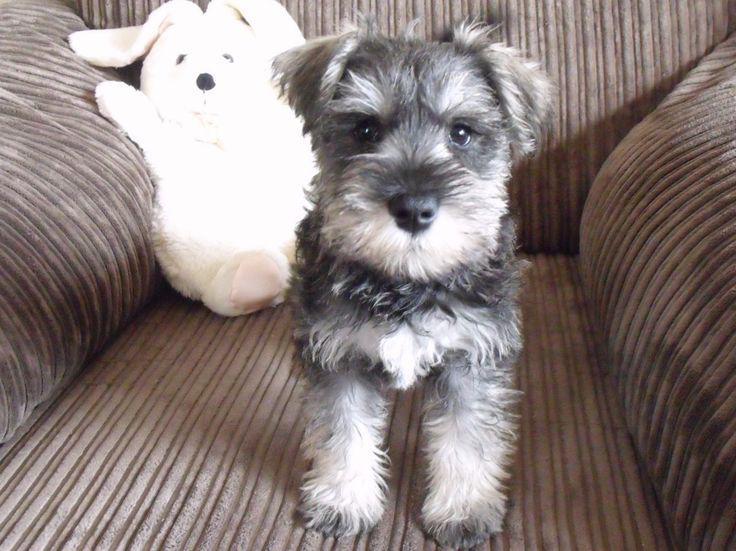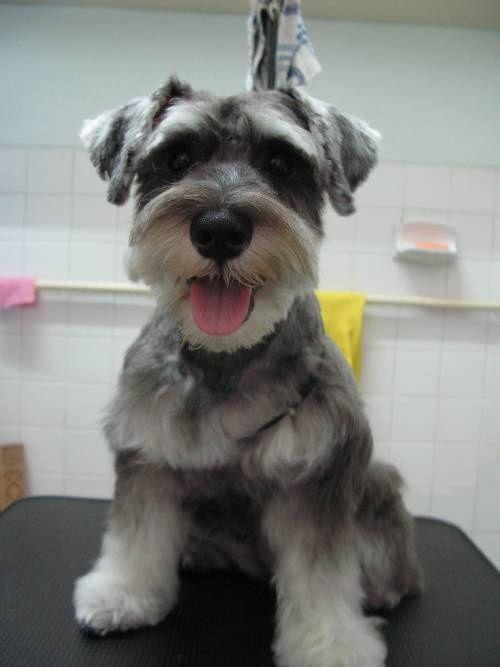The first image is the image on the left, the second image is the image on the right. Examine the images to the left and right. Is the description "There are two dogs sitting down." accurate? Answer yes or no. Yes. The first image is the image on the left, the second image is the image on the right. Evaluate the accuracy of this statement regarding the images: "There is a dog wearing a collar and facing left in one image.". Is it true? Answer yes or no. No. 